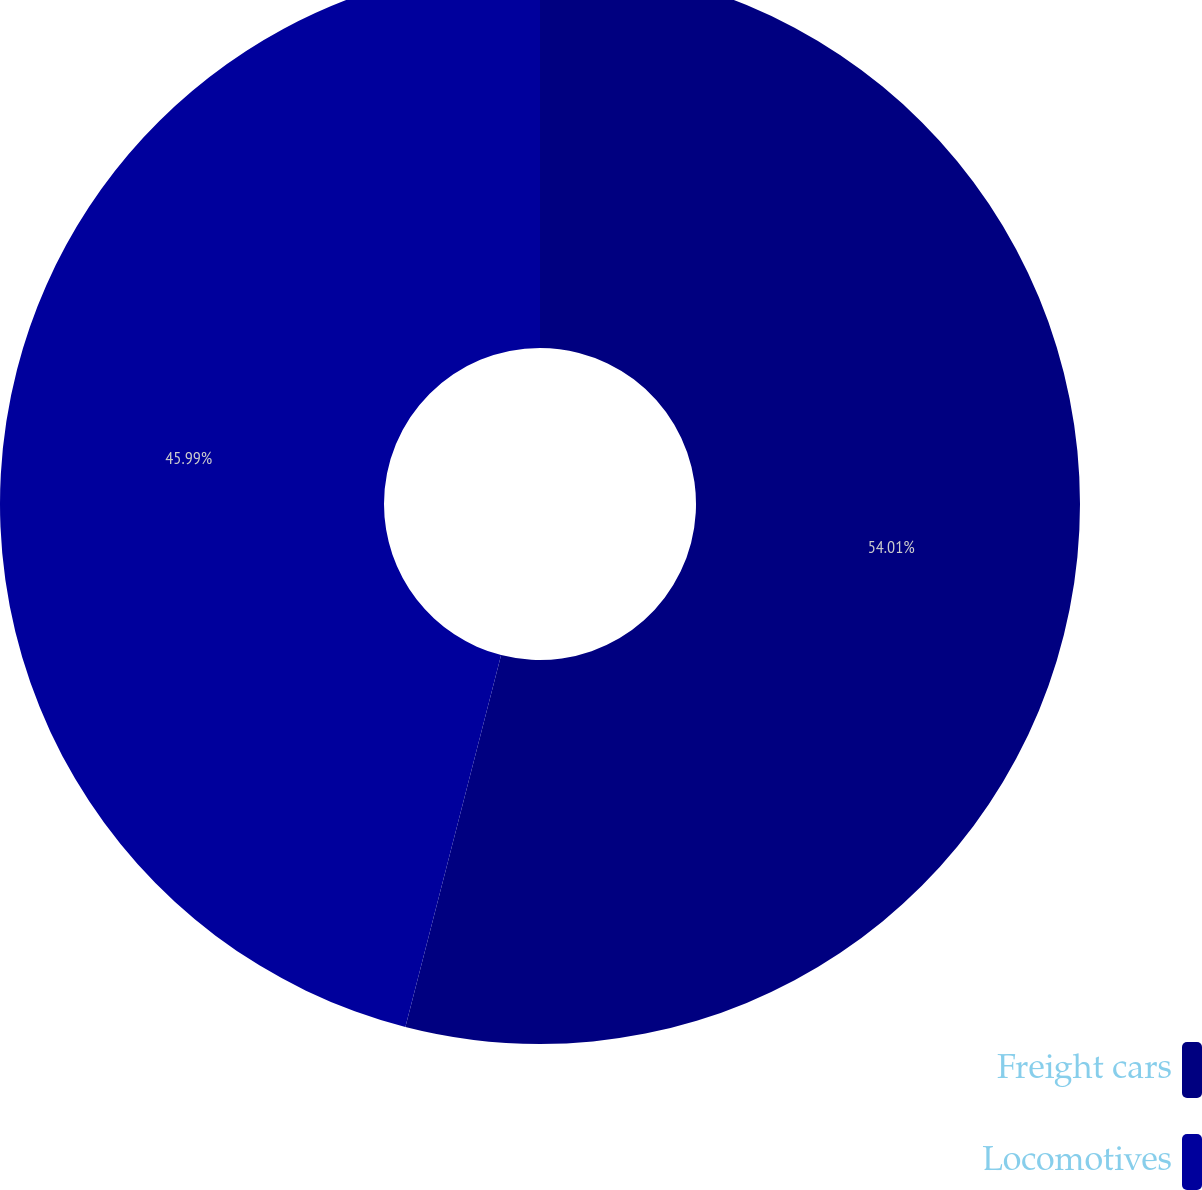<chart> <loc_0><loc_0><loc_500><loc_500><pie_chart><fcel>Freight cars<fcel>Locomotives<nl><fcel>54.01%<fcel>45.99%<nl></chart> 